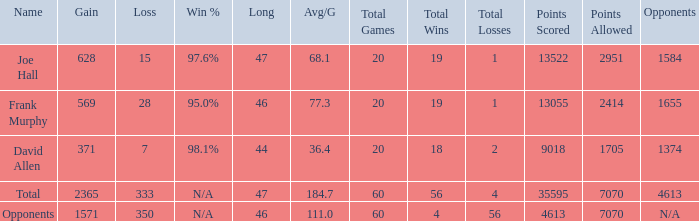How much Avg/G has a Gain smaller than 1571, and a Long smaller than 46? 1.0. 